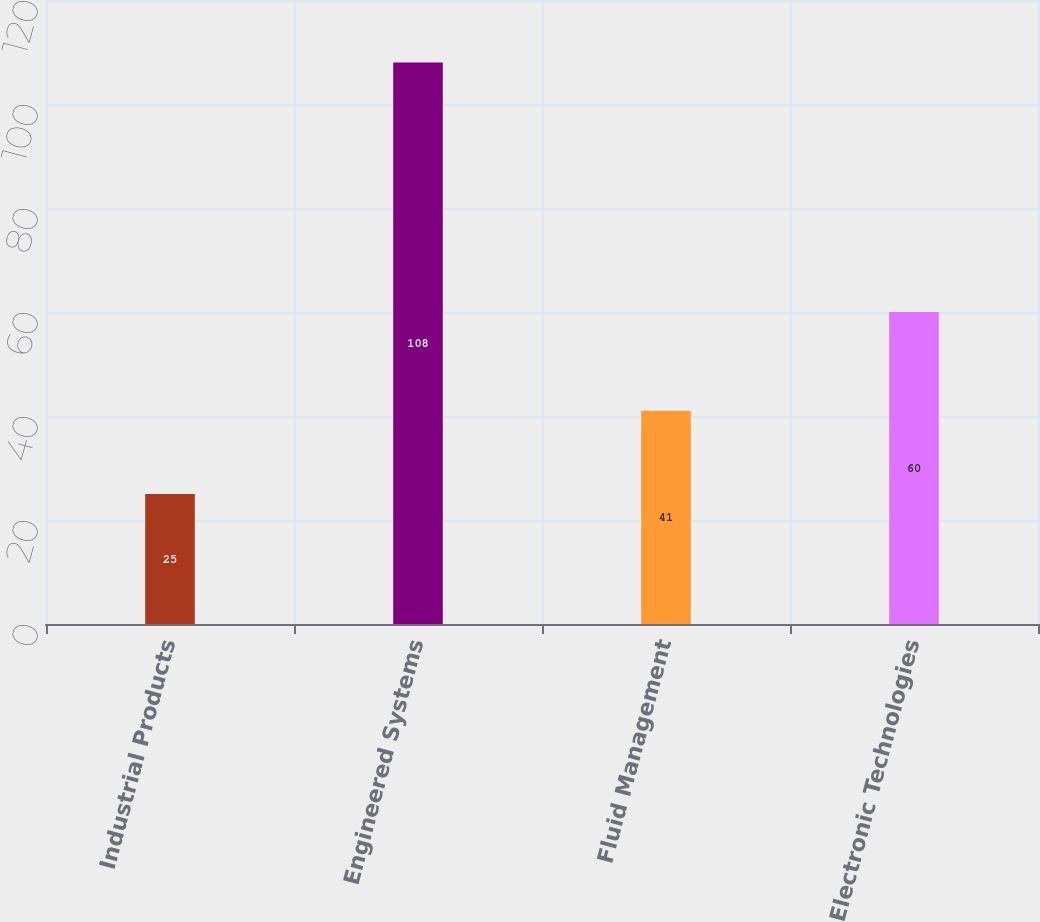Convert chart. <chart><loc_0><loc_0><loc_500><loc_500><bar_chart><fcel>Industrial Products<fcel>Engineered Systems<fcel>Fluid Management<fcel>Electronic Technologies<nl><fcel>25<fcel>108<fcel>41<fcel>60<nl></chart> 